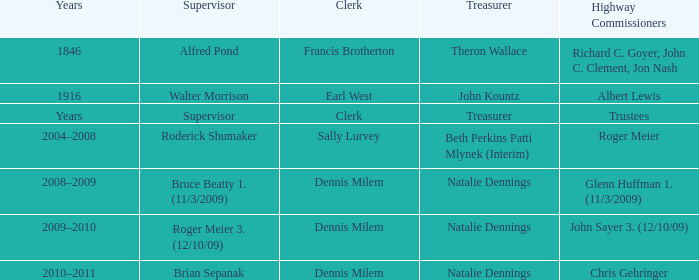Who was the clerk when the highway commissioner was Albert Lewis? Earl West. 